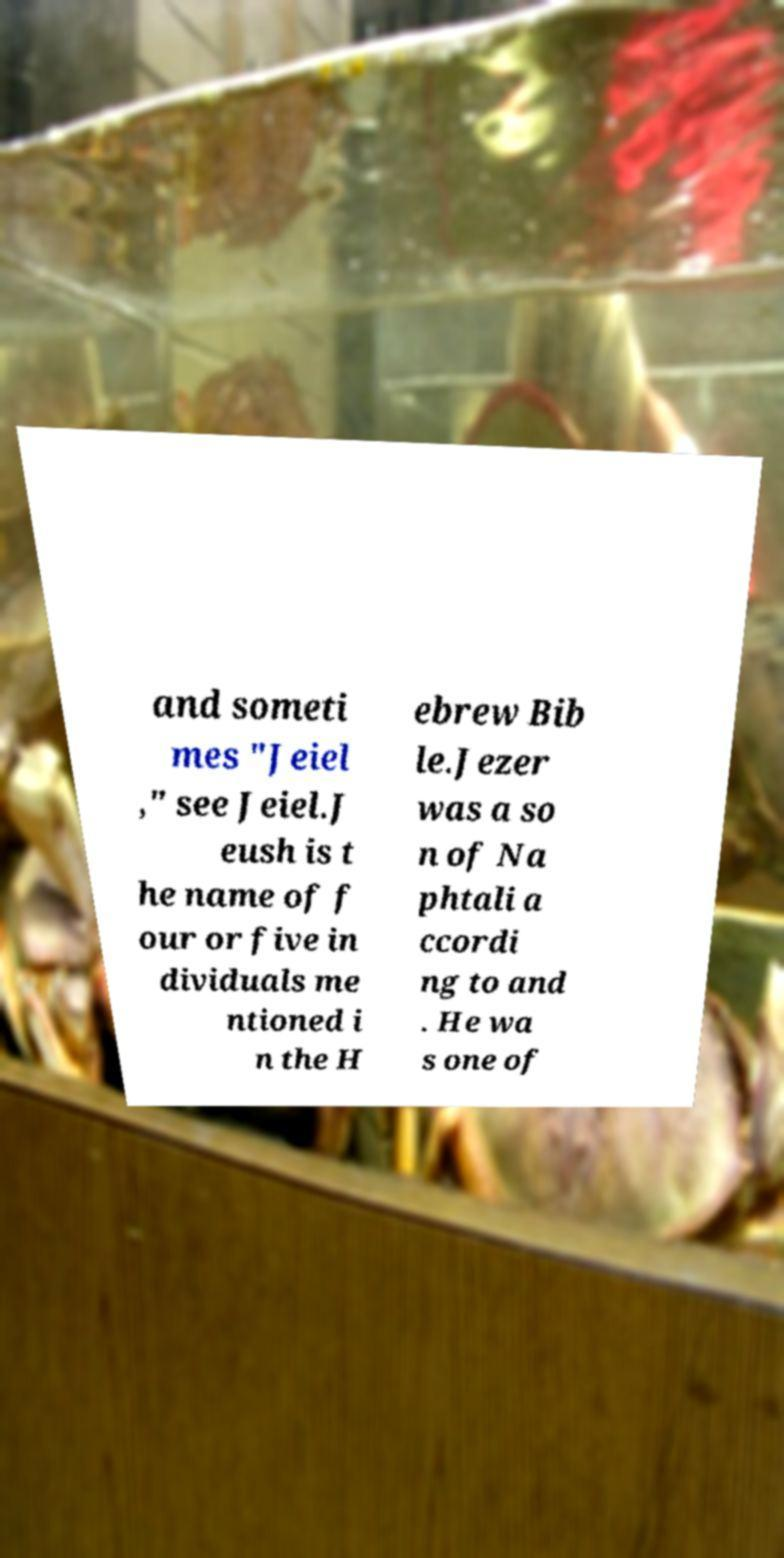I need the written content from this picture converted into text. Can you do that? and someti mes "Jeiel ," see Jeiel.J eush is t he name of f our or five in dividuals me ntioned i n the H ebrew Bib le.Jezer was a so n of Na phtali a ccordi ng to and . He wa s one of 